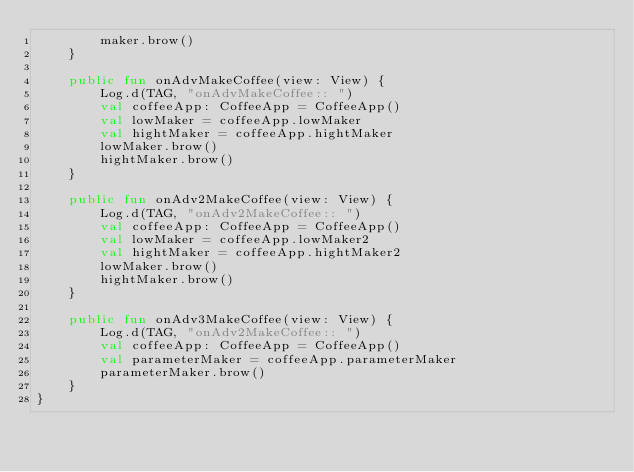Convert code to text. <code><loc_0><loc_0><loc_500><loc_500><_Kotlin_>        maker.brow()
    }

    public fun onAdvMakeCoffee(view: View) {
        Log.d(TAG, "onAdvMakeCoffee:: ")
        val coffeeApp: CoffeeApp = CoffeeApp()
        val lowMaker = coffeeApp.lowMaker
        val hightMaker = coffeeApp.hightMaker
        lowMaker.brow()
        hightMaker.brow()
    }

    public fun onAdv2MakeCoffee(view: View) {
        Log.d(TAG, "onAdv2MakeCoffee:: ")
        val coffeeApp: CoffeeApp = CoffeeApp()
        val lowMaker = coffeeApp.lowMaker2
        val hightMaker = coffeeApp.hightMaker2
        lowMaker.brow()
        hightMaker.brow()
    }

    public fun onAdv3MakeCoffee(view: View) {
        Log.d(TAG, "onAdv2MakeCoffee:: ")
        val coffeeApp: CoffeeApp = CoffeeApp()
        val parameterMaker = coffeeApp.parameterMaker
        parameterMaker.brow()
    }
}</code> 